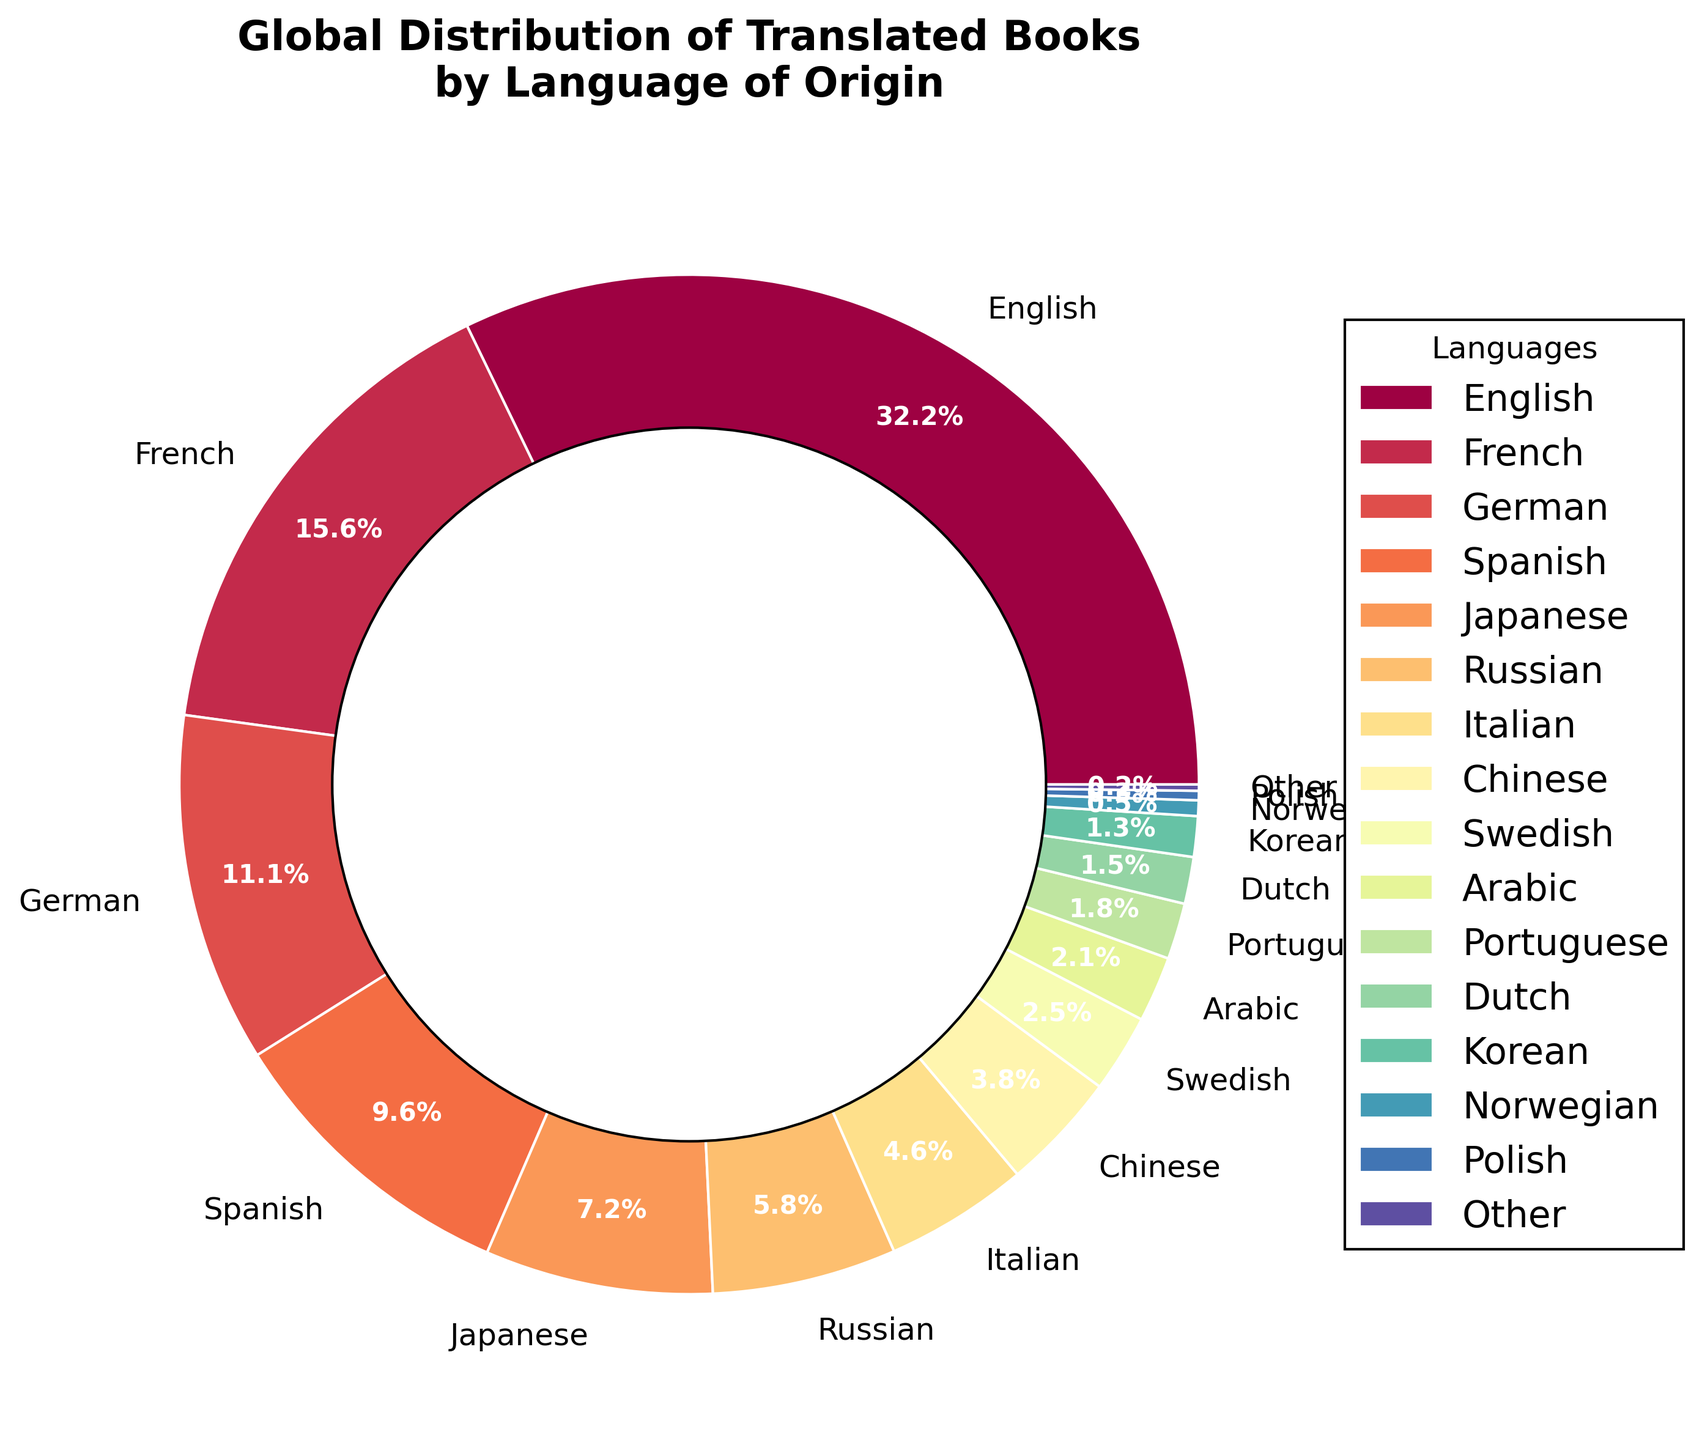Which language contributes the most to the distribution of translated books? From the pie chart, the largest segment is labeled "English" with 32.5%. This indicates English is the most contributing language to the distribution of translated books.
Answer: English What is the combined percentage of books translated from German and Spanish? The chart shows German contributes 11.2% and Spanish contributes 9.7%. Adding these percentages together: 11.2 + 9.7 = 20.9%.
Answer: 20.9% How much higher is the percentage of books translated from French compared to Italian? The percentage for French is 15.8% and for Italian is 4.6%. Subtract the Italian percentage from the French percentage: 15.8 - 4.6 = 11.2%.
Answer: 11.2% Which language category has the smallest share in the chart? The smallest segment on the chart is labeled "Other" with 0.2%, indicating it has the smallest share.
Answer: Other What is the total percentage of books translated from languages that contribute less than 5% each? Summing the percentages of languages with less than 5%: Italian (4.6) + Chinese (3.8) + Swedish (2.5) + Arabic (2.1) + Portuguese (1.8) + Dutch (1.5) + Korean (1.3) + Norwegian (0.5) + Polish (0.3) + Other (0.2) = 18.6%.
Answer: 18.6% Is the percentage of books translated from Japanese greater than that from Russian? According to the chart, Japanese contributes 7.3% and Russian contributes 5.9%. Since 7.3% is greater than 5.9%, the percentage of books translated from Japanese is indeed greater than from Russian.
Answer: Yes Which language origin ranks just above Swedish in terms of the percentage of translated books? The chart shows Swedish has 2.5%. The next highest segment is labeled "Chinese" with 3.8%, so Chinese is just above Swedish.
Answer: Chinese How many languages contribute less than 3% each to the distribution of translated books? From the chart: Swedish (2.5), Arabic (2.1), Portuguese (1.8), Dutch (1.5), Korean (1.3), Norwegian (0.5), Polish (0.3), Other (0.2). Counting these categories gives us 8 languages.
Answer: 8 What is the average percentage of books translated from English, French, and German? The percentages are English (32.5), French (15.8), and German (11.2). Calculate the average: (32.5 + 15.8 + 11.2) / 3 = 59.5 / 3 ≈ 19.83%.
Answer: 19.83% What percentage more books are translated from Spanish than from Arabic? Spanish contributes 9.7% while Arabic contributes 2.1%. The difference is: 9.7 - 2.1 = 7.6%.
Answer: 7.6% 